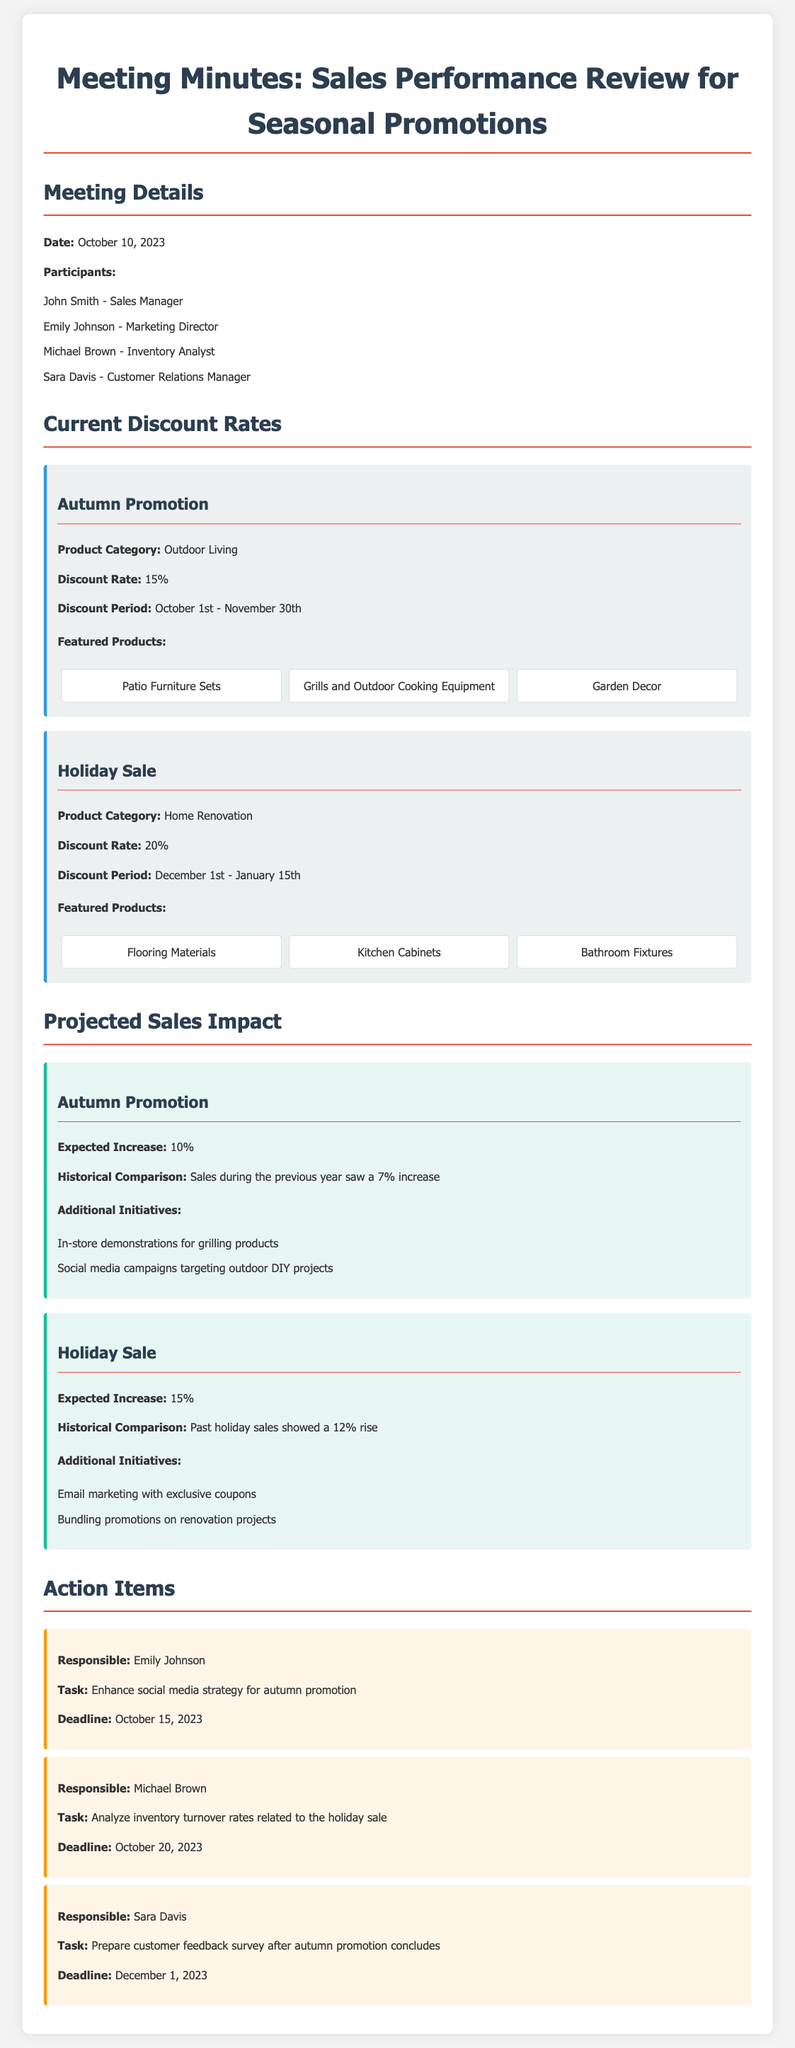What is the date of the meeting? The date of the meeting is explicitly mentioned in the document as October 10, 2023.
Answer: October 10, 2023 What is the discount rate for the Holiday Sale? The document specifies the discount rate for the Holiday Sale as 20%.
Answer: 20% What product categories are involved in the Autumn Promotion? The relevant product category for the Autumn Promotion is stated as Outdoor Living.
Answer: Outdoor Living What is the expected sales increase from the Autumn Promotion? The expected increase from the Autumn Promotion is detailed in the document as 10%.
Answer: 10% Who is responsible for enhancing the social media strategy? The document lists Emily Johnson as responsible for the task of enhancing the social media strategy.
Answer: Emily Johnson What additional initiative is suggested for the Holiday Sale? The document mentions email marketing with exclusive coupons as an additional initiative for the Holiday Sale.
Answer: Email marketing with exclusive coupons What is the deadline for the customer feedback survey preparation? The preparation deadline for the customer feedback survey is specified as December 1, 2023.
Answer: December 1, 2023 What was last year's sales increase during the Autumn Promotion? The document indicates that historical comparison showed a 7% increase in sales during the previous year.
Answer: 7% 